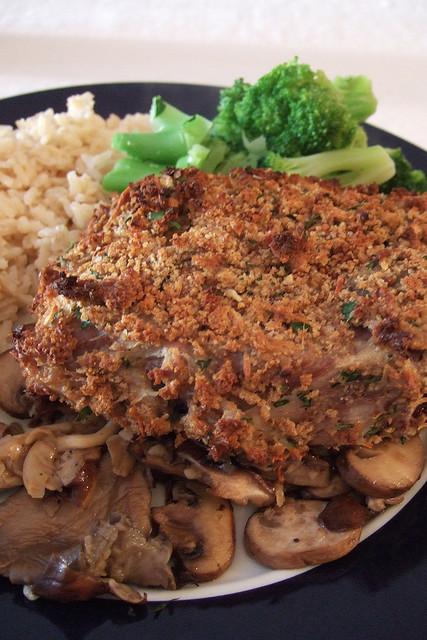Is there cauliflower in the dish?
Write a very short answer. No. What is on the plate?
Concise answer only. Dinner. Where are the mushrooms?
Answer briefly. Plate. Could this be Asian Fusion?
Be succinct. No. What kind of noodles are in the dish?
Quick response, please. Rice. Has most of the food on this plate been eaten?
Answer briefly. No. How many spatula's are visible?
Keep it brief. 0. Was this meal prepared at home?
Keep it brief. Yes. What kind of meat is next to the veggies?
Give a very brief answer. Pork. Is there a fork?
Quick response, please. No. What type of dish is used?
Short answer required. Plate. Does the chicken appear to have specks of white rice on it?
Short answer required. No. What is green in the picture?
Be succinct. Broccoli. What is underneath the breaded pieces of food?
Answer briefly. Mushrooms. What is under the chicken?
Concise answer only. Mushrooms. Does this meal contain grain?
Concise answer only. Yes. What type of seeds are on the meal?
Quick response, please. None. Is the meat overcooked?
Answer briefly. No. Does this look like a vegetarian would eat it?
Give a very brief answer. No. Is this Italian or Asian cuisine?
Keep it brief. Asian. What is the color of the plate?
Give a very brief answer. White. What is the green garnish on top of the pasta?
Short answer required. Broccoli. Is this an vegetarian voice?
Write a very short answer. No. What color is on the rim of the dish?
Keep it brief. Black. What color is the plate?
Answer briefly. White. What kind of sea creature is this from?
Write a very short answer. Fish. Is a vegetable on the plate?
Short answer required. Yes. Would this make a healthy meal?
Answer briefly. Yes. What is the brown material in the dish?
Write a very short answer. Meat. 